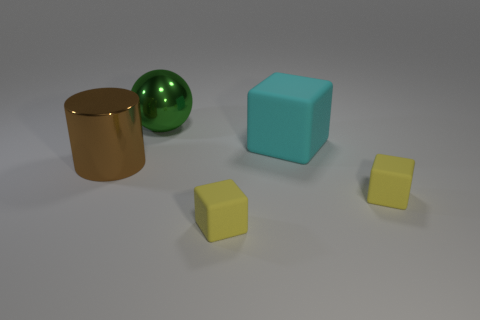Subtract all blue cylinders. How many yellow blocks are left? 2 Subtract all cyan matte cubes. How many cubes are left? 2 Subtract 1 blocks. How many blocks are left? 2 Add 1 tiny red objects. How many objects exist? 6 Add 2 small brown shiny cylinders. How many small brown shiny cylinders exist? 2 Subtract 0 blue spheres. How many objects are left? 5 Subtract all cylinders. How many objects are left? 4 Subtract all yellow matte blocks. Subtract all cyan rubber objects. How many objects are left? 2 Add 5 green shiny spheres. How many green shiny spheres are left? 6 